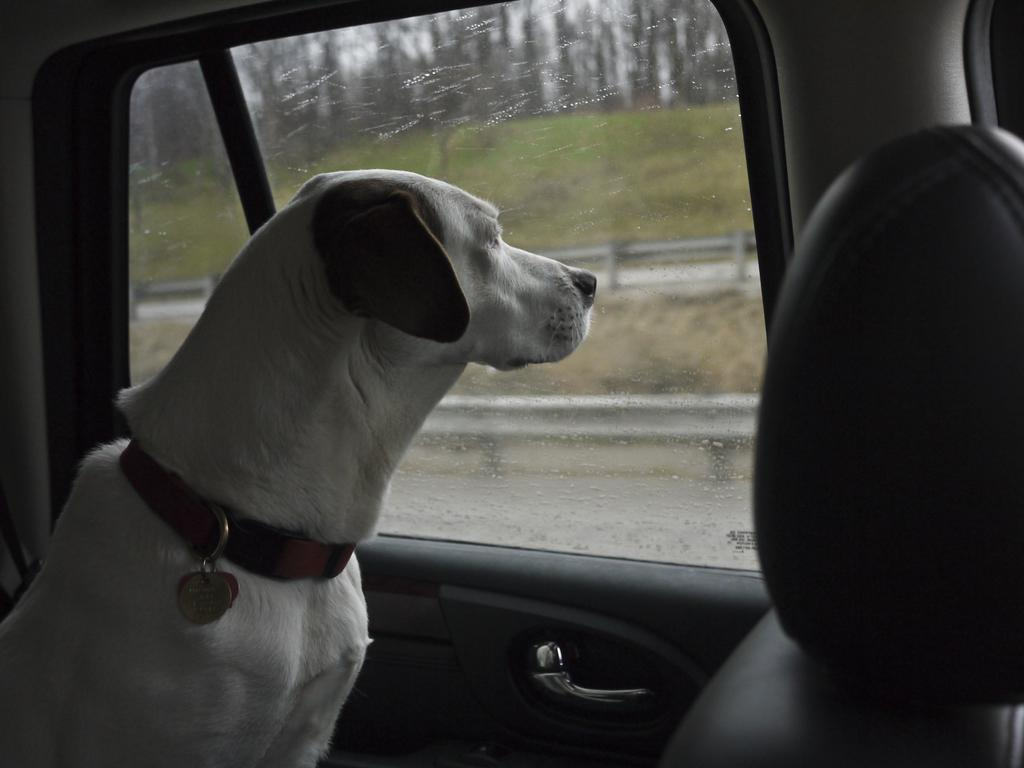What is inside the vehicle in the image? There is a dog inside the vehicle in the image. How is the dog secured in the vehicle? The dog is secured with a belt in the vehicle. What can be seen through the glass of the vehicle? The surroundings can be seen through the glass, including a fence, grass, trees, and the sky. What time does the clock on the dashboard show in the image? There is no clock visible in the image, so we cannot determine the time. 